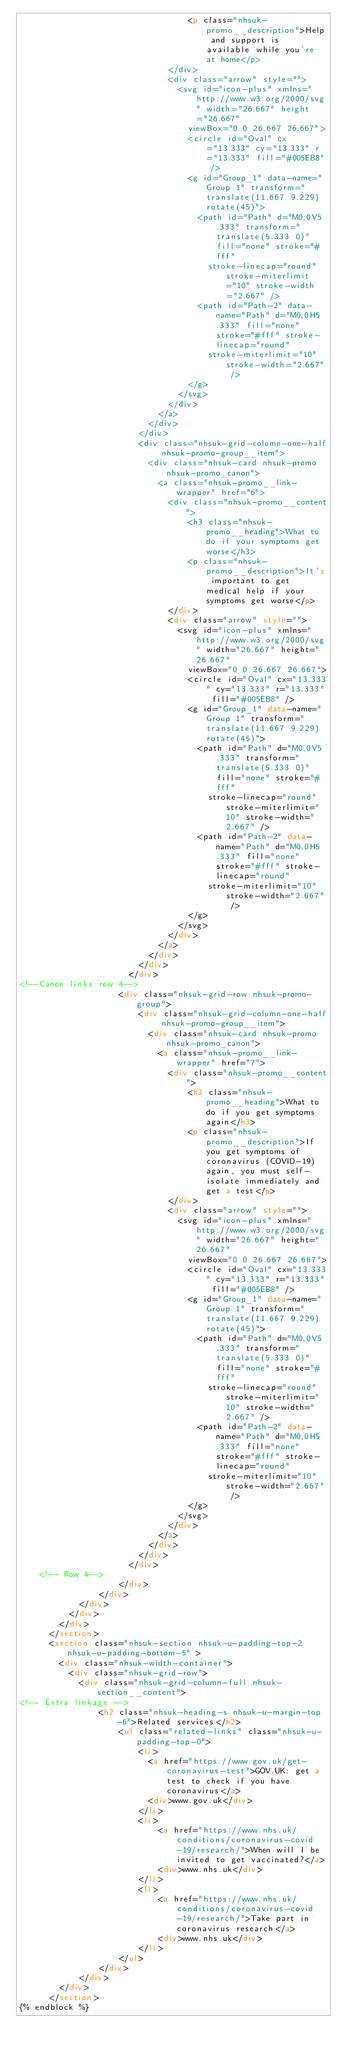Convert code to text. <code><loc_0><loc_0><loc_500><loc_500><_HTML_>								  <p class="nhsuk-promo__description">Help and support is available while you're at home</p>
							  </div>
							  <div class="arrow" style="">
								<svg id="icon-plus" xmlns="http://www.w3.org/2000/svg" width="26.667" height="26.667"
								  viewBox="0 0 26.667 26.667">
								  <circle id="Oval" cx="13.333" cy="13.333" r="13.333" fill="#005EB8" />
								  <g id="Group_1" data-name="Group 1" transform="translate(11.667 9.229) rotate(45)">
									<path id="Path" d="M0,0V5.333" transform="translate(5.333 0)" fill="none" stroke="#fff"
									  stroke-linecap="round" stroke-miterlimit="10" stroke-width="2.667" />
									<path id="Path-2" data-name="Path" d="M0,0H5.333" fill="none" stroke="#fff" stroke-linecap="round"
									  stroke-miterlimit="10" stroke-width="2.667" />
								  </g>
								</svg>
							  </div>
							</a>
						  </div>
						</div>
						<div class="nhsuk-grid-column-one-half nhsuk-promo-group__item">
						  <div class="nhsuk-card nhsuk-promo nhsuk-promo_canon">
							<a class="nhsuk-promo__link-wrapper" href="6">
							  <div class="nhsuk-promo__content">
								  <h3 class="nhsuk-promo__heading">What to do if your symptoms get worse</h3>
								  <p class="nhsuk-promo__description">It's important to get medical help if your symptoms get worse</p>
							  </div>
							  <div class="arrow" style="">
								<svg id="icon-plus" xmlns="http://www.w3.org/2000/svg" width="26.667" height="26.667"
								  viewBox="0 0 26.667 26.667">
								  <circle id="Oval" cx="13.333" cy="13.333" r="13.333" fill="#005EB8" />
								  <g id="Group_1" data-name="Group 1" transform="translate(11.667 9.229) rotate(45)">
									<path id="Path" d="M0,0V5.333" transform="translate(5.333 0)" fill="none" stroke="#fff"
									  stroke-linecap="round" stroke-miterlimit="10" stroke-width="2.667" />
									<path id="Path-2" data-name="Path" d="M0,0H5.333" fill="none" stroke="#fff" stroke-linecap="round"
									  stroke-miterlimit="10" stroke-width="2.667" />
								  </g>
								</svg>
							  </div>
							</a>
						  </div>
						</div>
					  </div>
<!--Canon links row 4-->     
					<div class="nhsuk-grid-row nhsuk-promo-group">
						<div class="nhsuk-grid-column-one-half nhsuk-promo-group__item">
						  <div class="nhsuk-card nhsuk-promo nhsuk-promo_canon">
							<a class="nhsuk-promo__link-wrapper" href="7">
							  <div class="nhsuk-promo__content">
								  <h3 class="nhsuk-promo__heading">What to do if you get symptoms again</h3>
								  <p class="nhsuk-promo__description">If you get symptoms of coronavirus (COVID-19) again, you must self-isolate immediately and get a test</p>
							  </div>
							  <div class="arrow" style="">
								<svg id="icon-plus" xmlns="http://www.w3.org/2000/svg" width="26.667" height="26.667"
								  viewBox="0 0 26.667 26.667">
								  <circle id="Oval" cx="13.333" cy="13.333" r="13.333" fill="#005EB8" />
								  <g id="Group_1" data-name="Group 1" transform="translate(11.667 9.229) rotate(45)">
									<path id="Path" d="M0,0V5.333" transform="translate(5.333 0)" fill="none" stroke="#fff"
									  stroke-linecap="round" stroke-miterlimit="10" stroke-width="2.667" />
									<path id="Path-2" data-name="Path" d="M0,0H5.333" fill="none" stroke="#fff" stroke-linecap="round"
									  stroke-miterlimit="10" stroke-width="2.667" />
								  </g>
								</svg>
							  </div>
							</a>
						  </div>
						</div>
					  </div>
	<!-- Row 4-->
					</div>
				</div>
			</div>
          </div>
        </div>
      </section>
      <section class="nhsuk-section nhsuk-u-padding-top-2 nhsuk-u-padding-bottom-5" >
        <div class="nhsuk-width-container">
          <div class="nhsuk-grid-row">
            <div class="nhsuk-grid-column-full nhsuk-section__content">
<!-- Extra linkage -->
				<h2 class="nhsuk-heading-s nhsuk-u-margin-top-6">Related services</h2>
					<ul class="related-links" class="nhsuk-u-padding-top-0">
						<li>
						  <a href="https://www.gov.uk/get-coronavirus-test">GOV.UK: get a test to check if you have coronavirus</a>
						  <div>www.gov.uk</div>
						</li>
						<li>
							<a href="https://www.nhs.uk/conditions/coronavirus-covid-19/research/">When will I be invited to get vaccinated?</a>
							<div>www.nhs.uk</div>
						</li>
						<li>
							<a href="https://www.nhs.uk/conditions/coronavirus-covid-19/research/">Take part in coronavirus research</a>
							<div>www.nhs.uk</div>
						</li>
					</ul>
				</div>
			</div>
		</div>
      </section>
{% endblock %}

</code> 